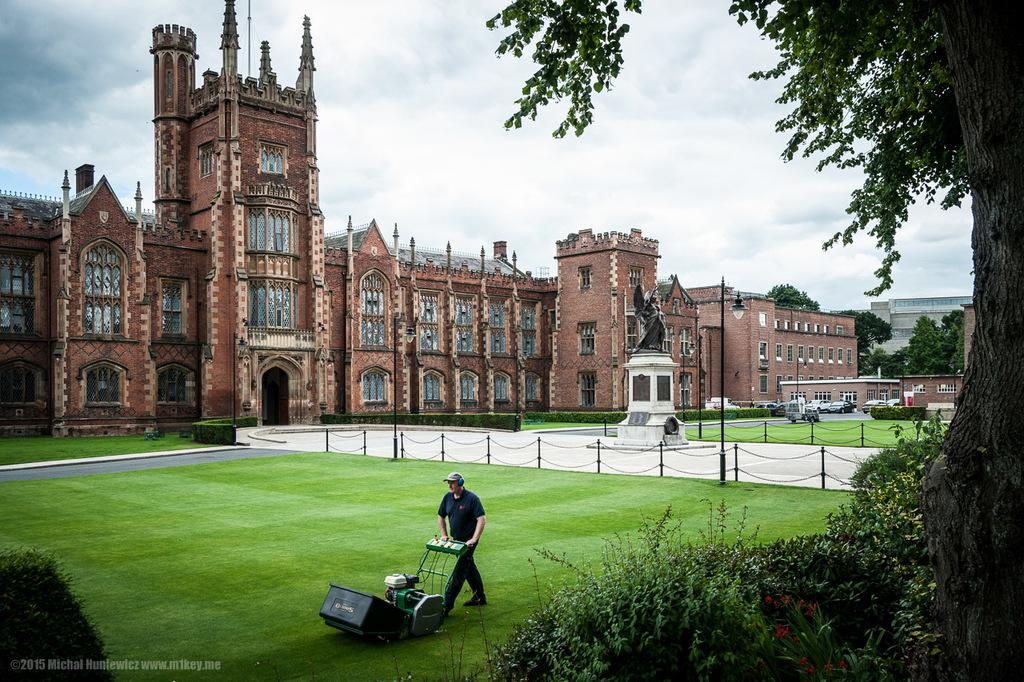Who is present in the image? There is a man in the image. What is the man holding in the image? The man is holding a grass cutter in the image. What type of vegetation can be seen in the image? There are plants, flowers, and grass in the image. What are the poles used for in the image? The purpose of the poles in the image is not specified, but they could be used for various purposes such as supporting structures or signage. What is the statue in the image depicting? The details of the statue in the image are not mentioned, so we cannot determine what it is depicting. What types of vehicles are visible in the image? The types of vehicles in the image are not specified, but they could be cars, trucks, or other forms of transportation. What type of structures can be seen in the image? There are buildings in the image. What is the surface on which the vehicles are traveling? There is a road in the image, which is likely the surface on which the vehicles are traveling. What type of trees are present in the image? The types of trees in the image are not specified. What is visible in the sky in the image? There is sky visible in the image, and it contains clouds. Where is the elbow located in the image? There is no mention of an elbow in the image, so we cannot determine its location. What discovery was made during the party in the image? There is no party or discovery mentioned in the image, so we cannot answer this question. 